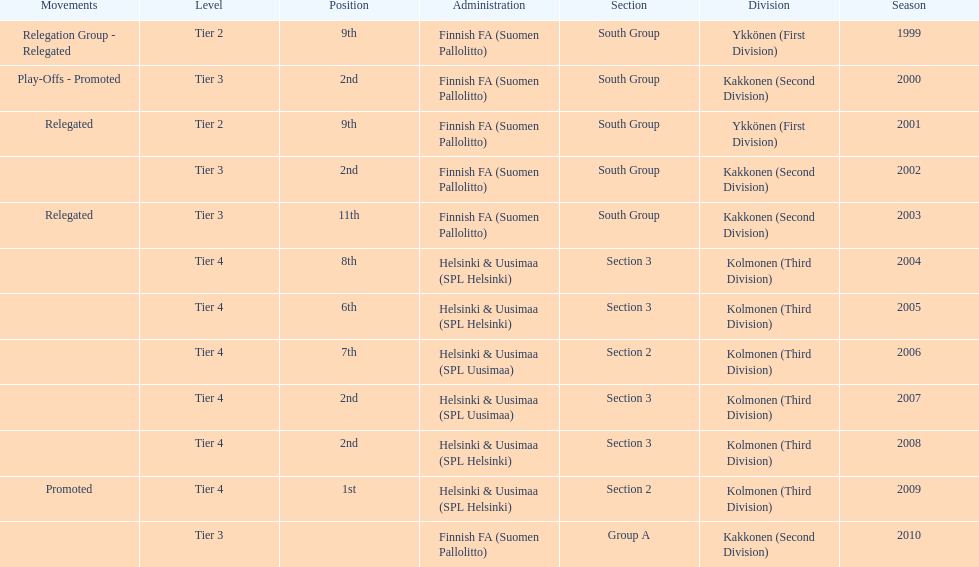In which subdivision were they primarily, part 3 or 2? 3. 